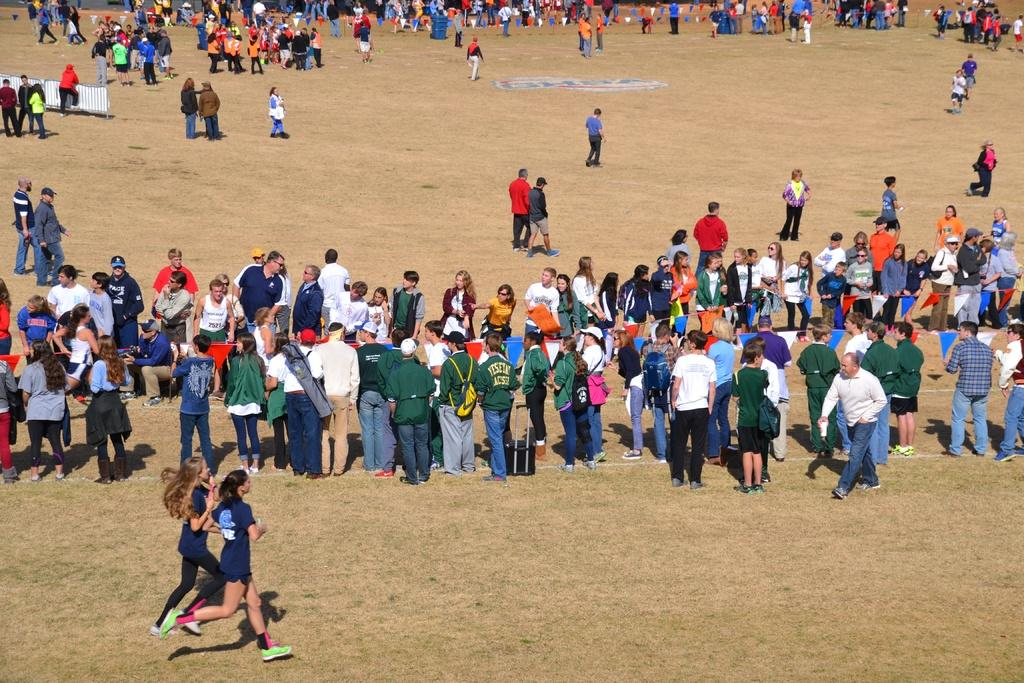What are the two persons in the image doing? The two persons in the image are running. What are the people on the ground doing? The people standing on the ground are not engaged in any specific activity in the image. What can be seen on the left side of the image? There is a metal fence on the left side of the image. What type of impulse is causing the frogs to jump in the image? There are no frogs present in the image, so there is no impulse causing them to jump. What design elements can be seen on the running persons' clothing in the image? The provided facts do not mention any design elements on the running persons' clothing, so we cannot answer this question based on the given information. 